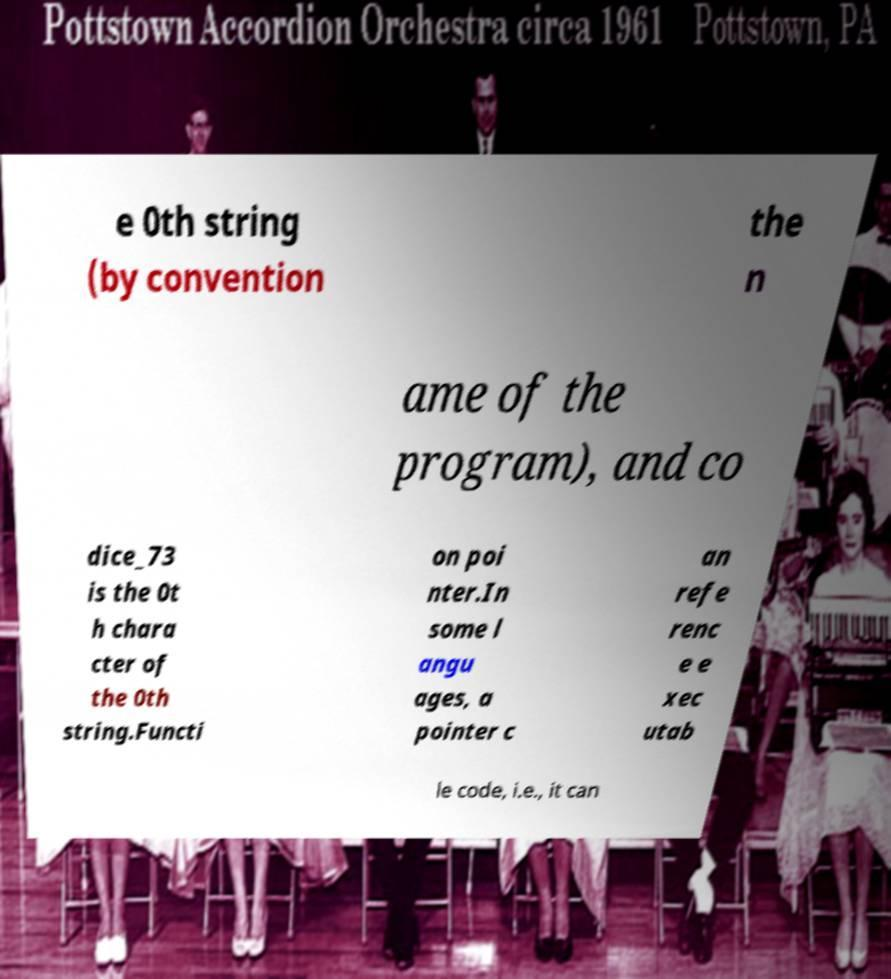Please identify and transcribe the text found in this image. e 0th string (by convention the n ame of the program), and co dice_73 is the 0t h chara cter of the 0th string.Functi on poi nter.In some l angu ages, a pointer c an refe renc e e xec utab le code, i.e., it can 